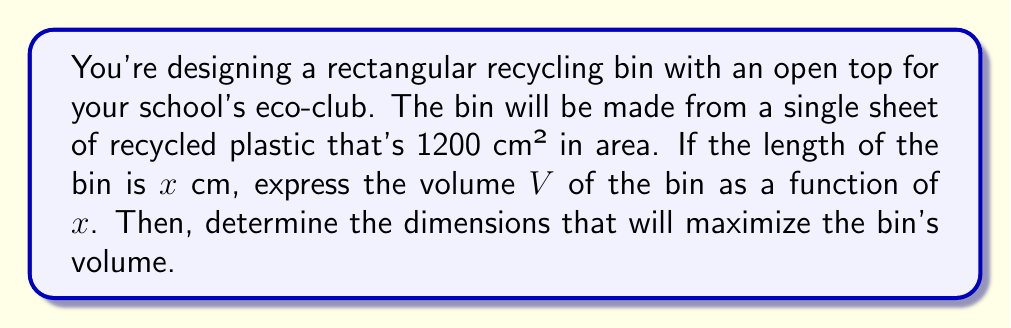Provide a solution to this math problem. Let's approach this step-by-step:

1) Let the length of the bin be $x$ cm and the width be $y$ cm. The height will be $h$ cm.

2) Given that the bin is made from a single sheet of 1200 cm², we can write:
   $$ 2xh + 2yh + xy = 1200 $$

3) Since the top is open, we don't include $xy$ in our area calculation:
   $$ 2xh + 2yh = 1200 $$

4) Solving for $h$:
   $$ h = \frac{1200}{2x + 2y} = \frac{600}{x + y} $$

5) The area of the base is $xy$, so:
   $$ y = \frac{1200 - 2xh}{x} = \frac{1200}{x} - 2h $$

6) Substituting the expression for $h$:
   $$ y = \frac{1200}{x} - 2(\frac{600}{x + y}) $$

7) The volume of the bin is $V = xyh$. Substituting our expressions:
   $$ V = x \cdot (\frac{1200}{x} - 2(\frac{600}{x + y})) \cdot \frac{600}{x + y} $$

8) Simplifying (this is a complex step, so we'll skip the details):
   $$ V = 720000 \cdot \frac{x}{(x + y)^2} $$

9) To maximize volume, we need $\frac{dV}{dx} = 0$. This occurs when $x = y$.

10) If $x = y$, then from step 2:
    $$ 4xh = 1200 $$
    $$ h = \frac{300}{x} $$

11) The volume is now:
    $$ V = x^2 \cdot \frac{300}{x} = 300x $$

12) To find the maximum, set $\frac{dV}{dx} = 0$:
    $$ \frac{dV}{dx} = 300 = 0 $$

This is always positive, meaning the volume increases with $x$. The maximum volume will occur at the largest possible $x$ value.

13) The largest possible $x$ (and $y$) is when $h$ is at its minimum. The minimum practical height might be around 10 cm.

14) If $h = 10$, then:
    $$ x = y = \frac{300}{10} = 30 \text{ cm} $$

Therefore, the optimal dimensions are 30 cm × 30 cm × 10 cm.
Answer: The volume function is $V = 720000 \cdot \frac{x}{(x + y)^2}$, where $x$ is the length and $y$ is the width. The optimal dimensions to maximize volume are approximately 30 cm × 30 cm × 10 cm. 